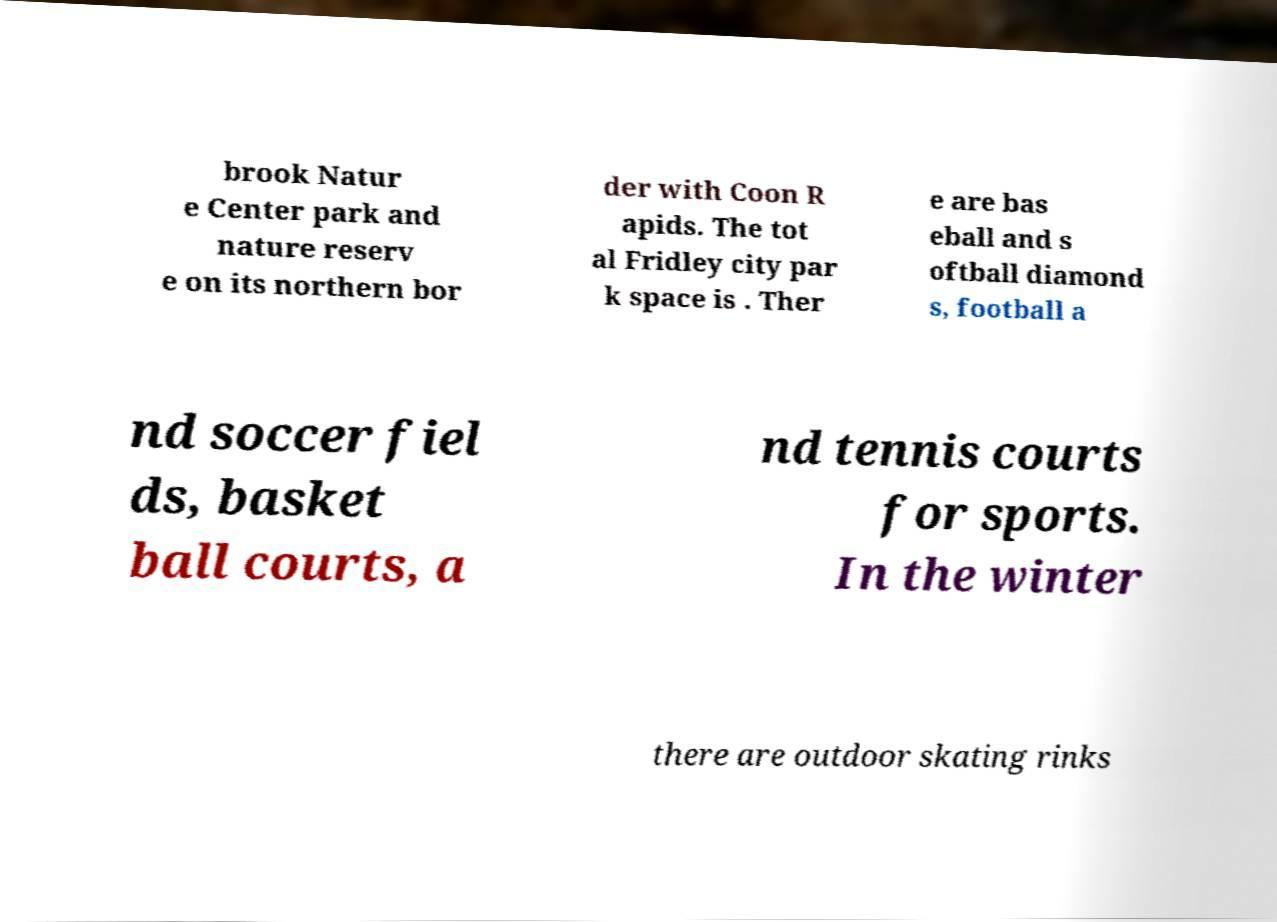Can you accurately transcribe the text from the provided image for me? brook Natur e Center park and nature reserv e on its northern bor der with Coon R apids. The tot al Fridley city par k space is . Ther e are bas eball and s oftball diamond s, football a nd soccer fiel ds, basket ball courts, a nd tennis courts for sports. In the winter there are outdoor skating rinks 